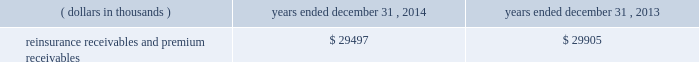Investments .
Fixed maturity and equity security investments available for sale , at market value , reflect unrealized appreciation and depreciation , as a result of temporary changes in market value during the period , in shareholders 2019 equity , net of income taxes in 201caccumulated other comprehensive income ( loss ) 201d in the consolidated balance sheets .
Fixed maturity and equity securities carried at fair value reflect fair value re- measurements as net realized capital gains and losses in the consolidated statements of operations and comprehensive income ( loss ) .
The company records changes in fair value for its fixed maturities available for sale , at market value through shareholders 2019 equity , net of taxes in accumulated other comprehensive income ( loss ) since cash flows from these investments will be primarily used to settle its reserve for losses and loss adjustment expense liabilities .
The company anticipates holding these investments for an extended period as the cash flow from interest and maturities will fund the projected payout of these liabilities .
Fixed maturities carried at fair value represent a portfolio of convertible bond securities , which have characteristics similar to equity securities and at times , designated foreign denominated fixed maturity securities , which will be used to settle loss and loss adjustment reserves in the same currency .
The company carries all of its equity securities at fair value except for mutual fund investments whose underlying investments are comprised of fixed maturity securities .
For equity securities , available for sale , at fair value , the company reflects changes in value as net realized capital gains and losses since these securities may be sold in the near term depending on financial market conditions .
Interest income on all fixed maturities and dividend income on all equity securities are included as part of net investment income in the consolidated statements of operations and comprehensive income ( loss ) .
Unrealized losses on fixed maturities , which are deemed other-than-temporary and related to the credit quality of a security , are charged to net income ( loss ) as net realized capital losses .
Short-term investments are stated at cost , which approximates market value .
Realized gains or losses on sales of investments are determined on the basis of identified cost .
For non- publicly traded securities , market prices are determined through the use of pricing models that evaluate securities relative to the u.s .
Treasury yield curve , taking into account the issue type , credit quality , and cash flow characteristics of each security .
For publicly traded securities , market value is based on quoted market prices or valuation models that use observable market inputs .
When a sector of the financial markets is inactive or illiquid , the company may use its own assumptions about future cash flows and risk-adjusted discount rates to determine fair value .
Retrospective adjustments are employed to recalculate the values of asset-backed securities .
Each acquisition lot is reviewed to recalculate the effective yield .
The recalculated effective yield is used to derive a book value as if the new yield were applied at the time of acquisition .
Outstanding principal factors from the time of acquisition to the adjustment date are used to calculate the prepayment history for all applicable securities .
Conditional prepayment rates , computed with life to date factor histories and weighted average maturities , are used to effect the calculation of projected and prepayments for pass-through security types .
Other invested assets include limited partnerships and rabbi trusts .
Limited partnerships are accounted for under the equity method of accounting , which can be recorded on a monthly or quarterly lag .
Uncollectible receivable balances .
The company provides reserves for uncollectible reinsurance recoverable and premium receivable balances based on management 2019s assessment of the collectability of the outstanding balances .
Such reserves are presented in the table below for the periods indicated. .

What was the ratio of the reinsurance receivables and premium receivables from 2014 to 2013? 
Rationale: the ratio of the reinsurance receivables and premium receivables from 2014 to 2013 is nearly 1 to 1
Computations: (29497 / 29905)
Answer: 0.98636. Investments .
Fixed maturity and equity security investments available for sale , at market value , reflect unrealized appreciation and depreciation , as a result of temporary changes in market value during the period , in shareholders 2019 equity , net of income taxes in 201caccumulated other comprehensive income ( loss ) 201d in the consolidated balance sheets .
Fixed maturity and equity securities carried at fair value reflect fair value re- measurements as net realized capital gains and losses in the consolidated statements of operations and comprehensive income ( loss ) .
The company records changes in fair value for its fixed maturities available for sale , at market value through shareholders 2019 equity , net of taxes in accumulated other comprehensive income ( loss ) since cash flows from these investments will be primarily used to settle its reserve for losses and loss adjustment expense liabilities .
The company anticipates holding these investments for an extended period as the cash flow from interest and maturities will fund the projected payout of these liabilities .
Fixed maturities carried at fair value represent a portfolio of convertible bond securities , which have characteristics similar to equity securities and at times , designated foreign denominated fixed maturity securities , which will be used to settle loss and loss adjustment reserves in the same currency .
The company carries all of its equity securities at fair value except for mutual fund investments whose underlying investments are comprised of fixed maturity securities .
For equity securities , available for sale , at fair value , the company reflects changes in value as net realized capital gains and losses since these securities may be sold in the near term depending on financial market conditions .
Interest income on all fixed maturities and dividend income on all equity securities are included as part of net investment income in the consolidated statements of operations and comprehensive income ( loss ) .
Unrealized losses on fixed maturities , which are deemed other-than-temporary and related to the credit quality of a security , are charged to net income ( loss ) as net realized capital losses .
Short-term investments are stated at cost , which approximates market value .
Realized gains or losses on sales of investments are determined on the basis of identified cost .
For non- publicly traded securities , market prices are determined through the use of pricing models that evaluate securities relative to the u.s .
Treasury yield curve , taking into account the issue type , credit quality , and cash flow characteristics of each security .
For publicly traded securities , market value is based on quoted market prices or valuation models that use observable market inputs .
When a sector of the financial markets is inactive or illiquid , the company may use its own assumptions about future cash flows and risk-adjusted discount rates to determine fair value .
Retrospective adjustments are employed to recalculate the values of asset-backed securities .
Each acquisition lot is reviewed to recalculate the effective yield .
The recalculated effective yield is used to derive a book value as if the new yield were applied at the time of acquisition .
Outstanding principal factors from the time of acquisition to the adjustment date are used to calculate the prepayment history for all applicable securities .
Conditional prepayment rates , computed with life to date factor histories and weighted average maturities , are used to effect the calculation of projected and prepayments for pass-through security types .
Other invested assets include limited partnerships and rabbi trusts .
Limited partnerships are accounted for under the equity method of accounting , which can be recorded on a monthly or quarterly lag .
Uncollectible receivable balances .
The company provides reserves for uncollectible reinsurance recoverable and premium receivable balances based on management 2019s assessment of the collectability of the outstanding balances .
Such reserves are presented in the table below for the periods indicated. .

What is the net change in the balance of reinsurance receivables and premium receivables from 2013 to 2014? 
Computations: (29497 - 29905)
Answer: -408.0. 